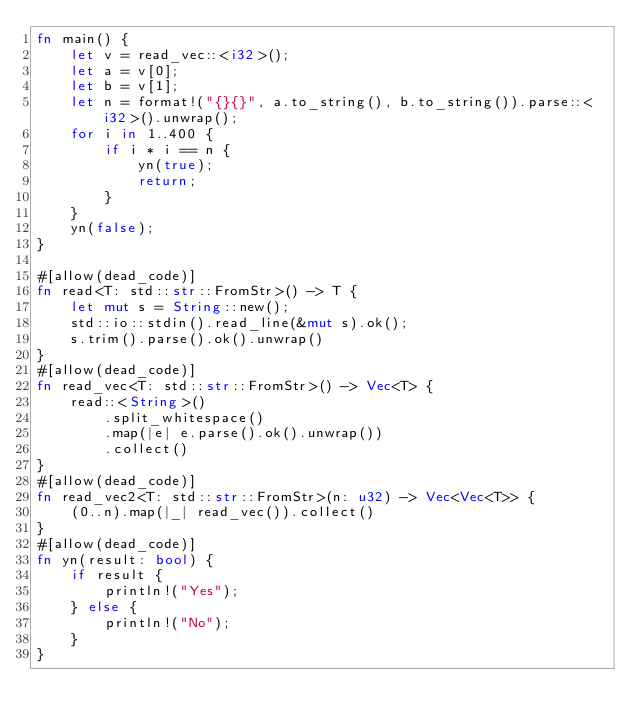Convert code to text. <code><loc_0><loc_0><loc_500><loc_500><_Rust_>fn main() {
    let v = read_vec::<i32>();
    let a = v[0];
    let b = v[1];
    let n = format!("{}{}", a.to_string(), b.to_string()).parse::<i32>().unwrap();
    for i in 1..400 {
        if i * i == n {
            yn(true);
            return;
        }
    }
    yn(false);
}

#[allow(dead_code)]
fn read<T: std::str::FromStr>() -> T {
    let mut s = String::new();
    std::io::stdin().read_line(&mut s).ok();
    s.trim().parse().ok().unwrap()
}
#[allow(dead_code)]
fn read_vec<T: std::str::FromStr>() -> Vec<T> {
    read::<String>()
        .split_whitespace()
        .map(|e| e.parse().ok().unwrap())
        .collect()
}
#[allow(dead_code)]
fn read_vec2<T: std::str::FromStr>(n: u32) -> Vec<Vec<T>> {
    (0..n).map(|_| read_vec()).collect()
}
#[allow(dead_code)]
fn yn(result: bool) {
    if result {
        println!("Yes");
    } else {
        println!("No");
    }
}
</code> 